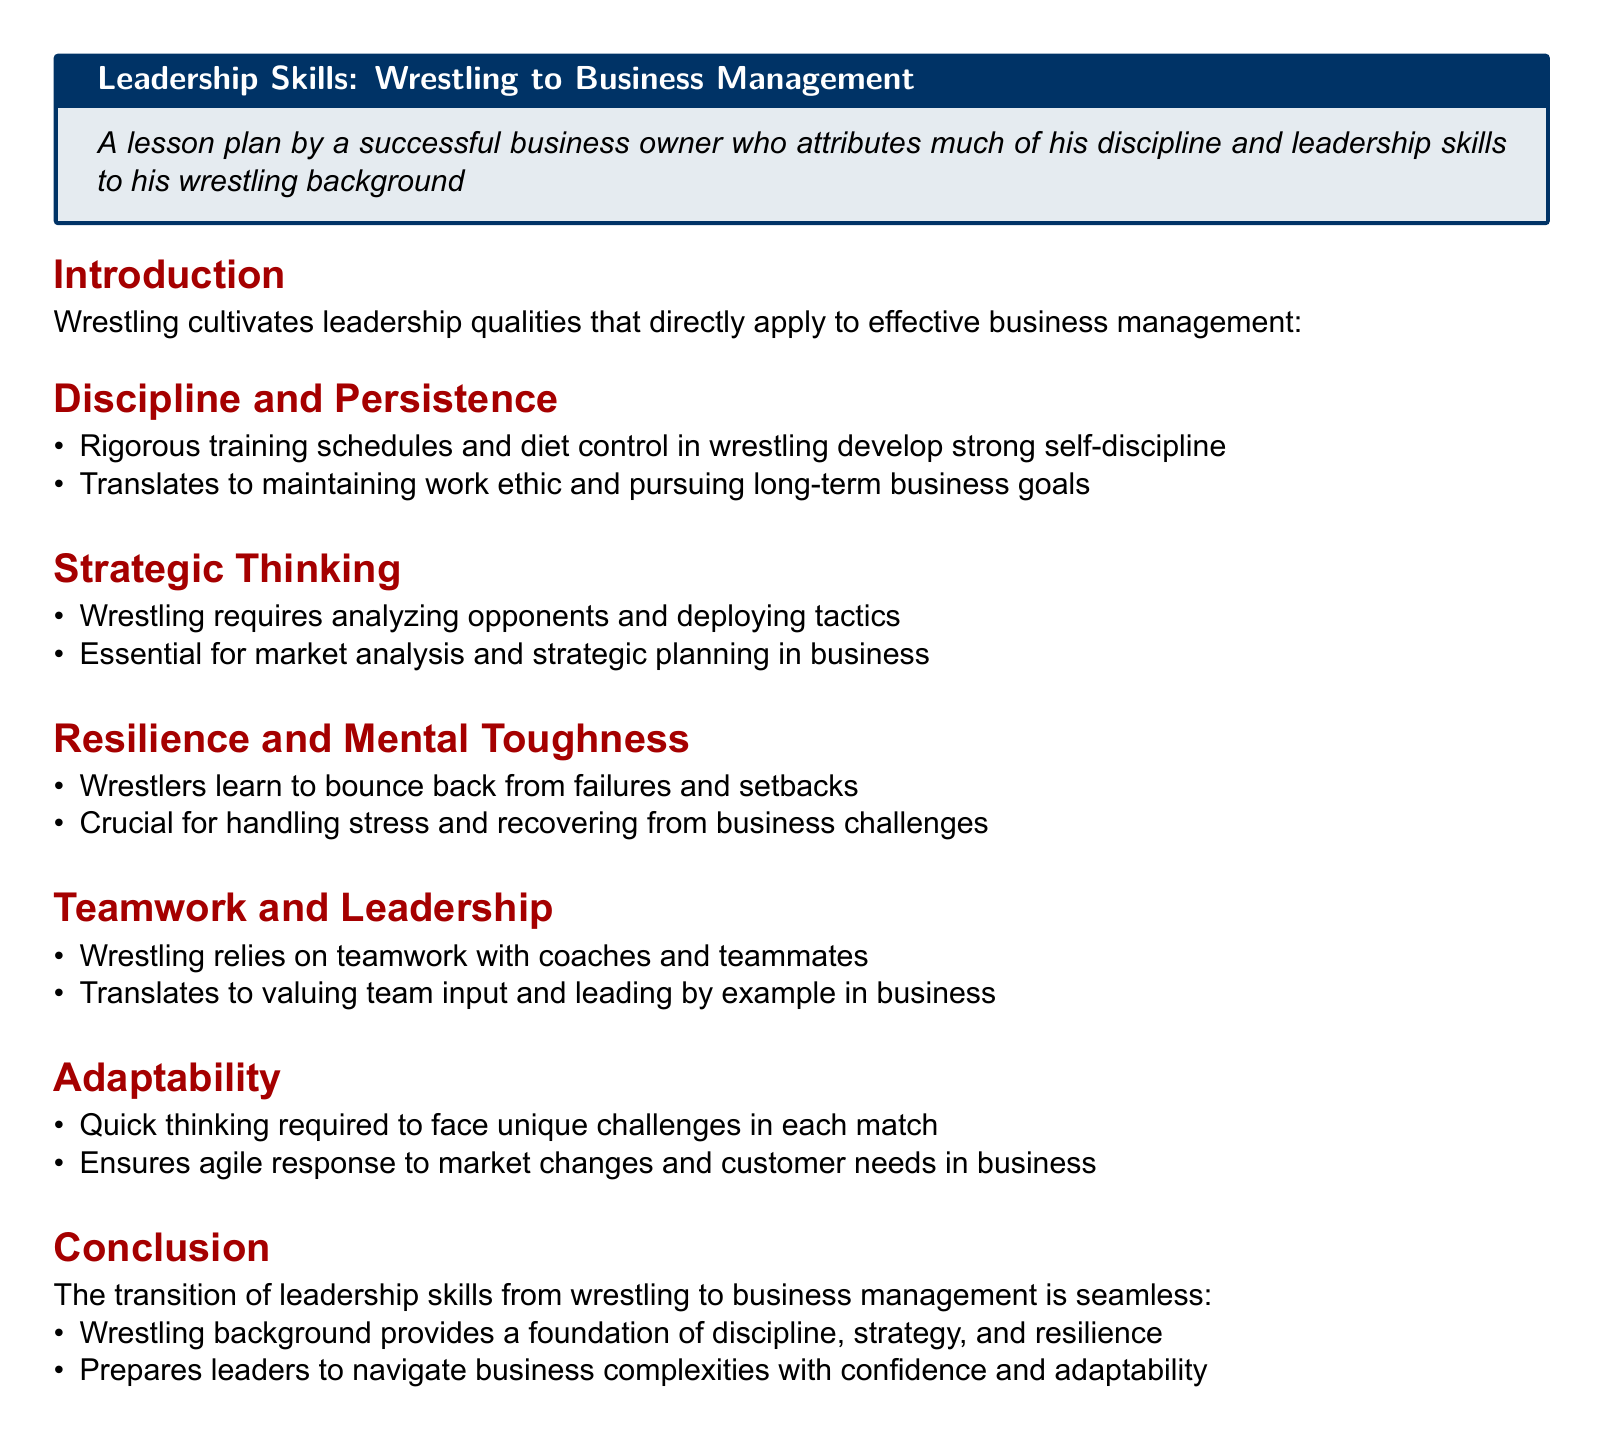What are the core leadership qualities developed through wrestling? The document states leadership qualities such as discipline, strategic thinking, resilience, teamwork, and adaptability are developed through wrestling.
Answer: Discipline, strategic thinking, resilience, teamwork, adaptability What aspect of wrestling helps in strategic planning? The document mentions that wrestling requires analyzing opponents and deploying tactics, which is essential for strategic planning in business.
Answer: Analyzing opponents and deploying tactics How does wrestling training develop self-discipline? The document details that rigorous training schedules and diet control in wrestling contribute to strong self-discipline.
Answer: Rigorous training schedules and diet control What is one way wrestlers learn resilience? The document explains that wrestlers learn to bounce back from failures and setbacks.
Answer: Bounce back from failures and setbacks In what way does teamwork in wrestling translate to business? The document states that wrestling relies on teamwork with coaches and teammates, which translates to valuing team input and leading by example in business.
Answer: Valuing team input and leading by example What is the document type? The content is structured as a lesson plan, focusing on leadership skills.
Answer: Lesson plan What does adaptability in wrestling prepare leaders for in business? The document indicates that quick thinking in wrestling prepares leaders for agile responses to market changes and customer needs in business.
Answer: Agile responses to market changes and customer needs How does the introduction characterize wrestling's impact on business management? The introduction describes the cultivation of leadership qualities in wrestling that apply directly to effective business management.
Answer: Cultivation of leadership qualities 